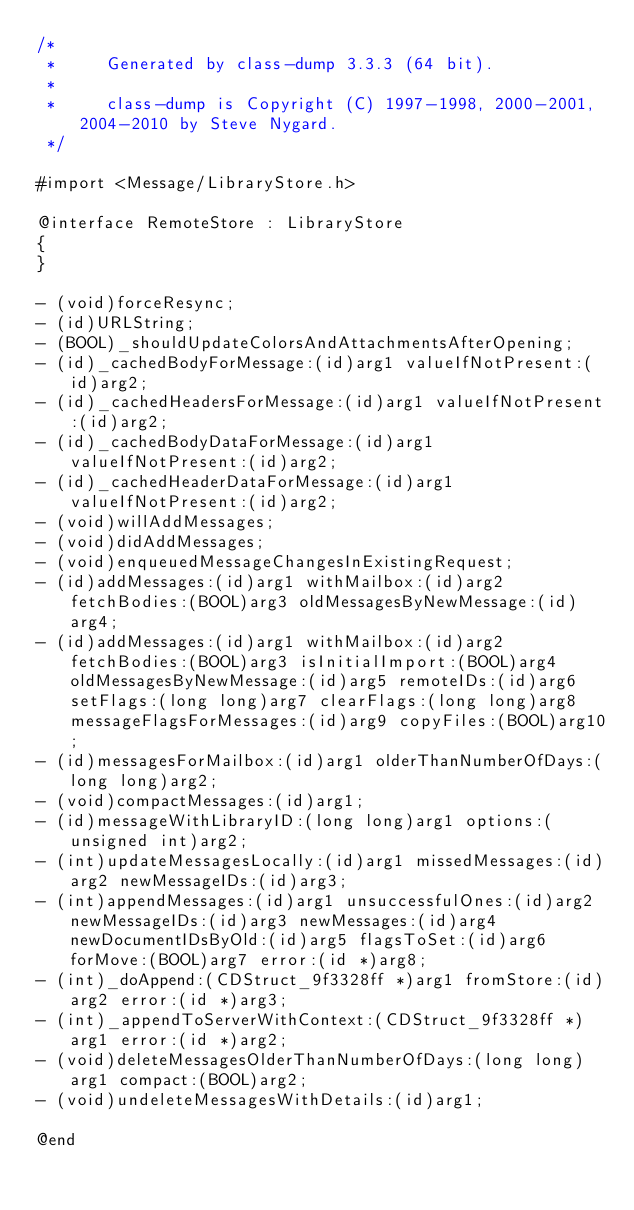<code> <loc_0><loc_0><loc_500><loc_500><_C_>/*
 *     Generated by class-dump 3.3.3 (64 bit).
 *
 *     class-dump is Copyright (C) 1997-1998, 2000-2001, 2004-2010 by Steve Nygard.
 */

#import <Message/LibraryStore.h>

@interface RemoteStore : LibraryStore
{
}

- (void)forceResync;
- (id)URLString;
- (BOOL)_shouldUpdateColorsAndAttachmentsAfterOpening;
- (id)_cachedBodyForMessage:(id)arg1 valueIfNotPresent:(id)arg2;
- (id)_cachedHeadersForMessage:(id)arg1 valueIfNotPresent:(id)arg2;
- (id)_cachedBodyDataForMessage:(id)arg1 valueIfNotPresent:(id)arg2;
- (id)_cachedHeaderDataForMessage:(id)arg1 valueIfNotPresent:(id)arg2;
- (void)willAddMessages;
- (void)didAddMessages;
- (void)enqueuedMessageChangesInExistingRequest;
- (id)addMessages:(id)arg1 withMailbox:(id)arg2 fetchBodies:(BOOL)arg3 oldMessagesByNewMessage:(id)arg4;
- (id)addMessages:(id)arg1 withMailbox:(id)arg2 fetchBodies:(BOOL)arg3 isInitialImport:(BOOL)arg4 oldMessagesByNewMessage:(id)arg5 remoteIDs:(id)arg6 setFlags:(long long)arg7 clearFlags:(long long)arg8 messageFlagsForMessages:(id)arg9 copyFiles:(BOOL)arg10;
- (id)messagesForMailbox:(id)arg1 olderThanNumberOfDays:(long long)arg2;
- (void)compactMessages:(id)arg1;
- (id)messageWithLibraryID:(long long)arg1 options:(unsigned int)arg2;
- (int)updateMessagesLocally:(id)arg1 missedMessages:(id)arg2 newMessageIDs:(id)arg3;
- (int)appendMessages:(id)arg1 unsuccessfulOnes:(id)arg2 newMessageIDs:(id)arg3 newMessages:(id)arg4 newDocumentIDsByOld:(id)arg5 flagsToSet:(id)arg6 forMove:(BOOL)arg7 error:(id *)arg8;
- (int)_doAppend:(CDStruct_9f3328ff *)arg1 fromStore:(id)arg2 error:(id *)arg3;
- (int)_appendToServerWithContext:(CDStruct_9f3328ff *)arg1 error:(id *)arg2;
- (void)deleteMessagesOlderThanNumberOfDays:(long long)arg1 compact:(BOOL)arg2;
- (void)undeleteMessagesWithDetails:(id)arg1;

@end

</code> 